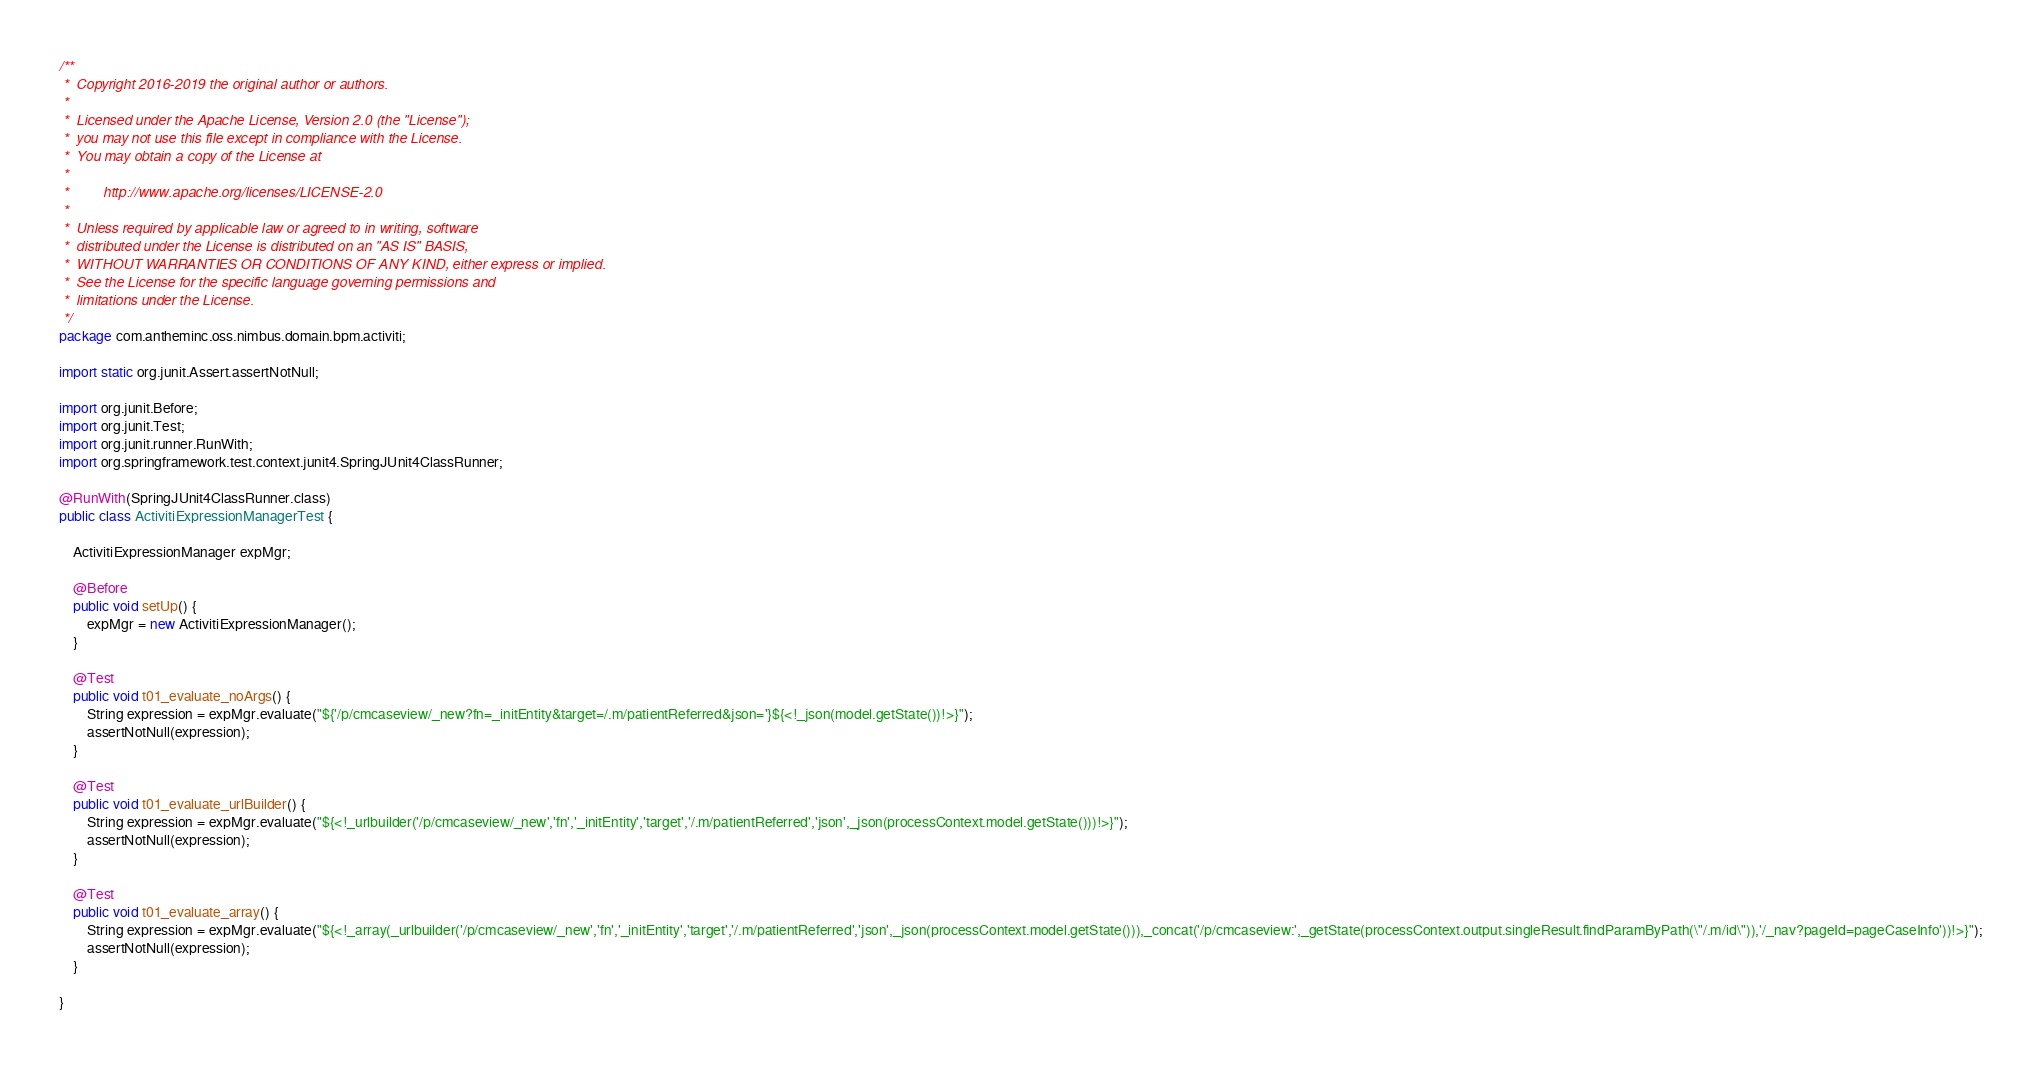<code> <loc_0><loc_0><loc_500><loc_500><_Java_>/**
 *  Copyright 2016-2019 the original author or authors.
 *
 *  Licensed under the Apache License, Version 2.0 (the "License");
 *  you may not use this file except in compliance with the License.
 *  You may obtain a copy of the License at
 *
 *         http://www.apache.org/licenses/LICENSE-2.0
 *
 *  Unless required by applicable law or agreed to in writing, software
 *  distributed under the License is distributed on an "AS IS" BASIS,
 *  WITHOUT WARRANTIES OR CONDITIONS OF ANY KIND, either express or implied.
 *  See the License for the specific language governing permissions and
 *  limitations under the License.
 */
package com.antheminc.oss.nimbus.domain.bpm.activiti;

import static org.junit.Assert.assertNotNull;

import org.junit.Before;
import org.junit.Test;
import org.junit.runner.RunWith;
import org.springframework.test.context.junit4.SpringJUnit4ClassRunner;

@RunWith(SpringJUnit4ClassRunner.class)
public class ActivitiExpressionManagerTest {
	
	ActivitiExpressionManager expMgr;
	
	@Before
	public void setUp() {
		expMgr = new ActivitiExpressionManager();
	}
	
	@Test
	public void t01_evaluate_noArgs() {
		String expression = expMgr.evaluate("${'/p/cmcaseview/_new?fn=_initEntity&target=/.m/patientReferred&json='}${<!_json(model.getState())!>}");
		assertNotNull(expression);
	}
	
	@Test
	public void t01_evaluate_urlBuilder() {
		String expression = expMgr.evaluate("${<!_urlbuilder('/p/cmcaseview/_new','fn','_initEntity','target','/.m/patientReferred','json',_json(processContext.model.getState()))!>}");
		assertNotNull(expression);
	}	
	
	@Test
	public void t01_evaluate_array() {
		String expression = expMgr.evaluate("${<!_array(_urlbuilder('/p/cmcaseview/_new','fn','_initEntity','target','/.m/patientReferred','json',_json(processContext.model.getState())),_concat('/p/cmcaseview:',_getState(processContext.output.singleResult.findParamByPath(\"/.m/id\")),'/_nav?pageId=pageCaseInfo'))!>}");
		assertNotNull(expression);
	}		
	
}
</code> 